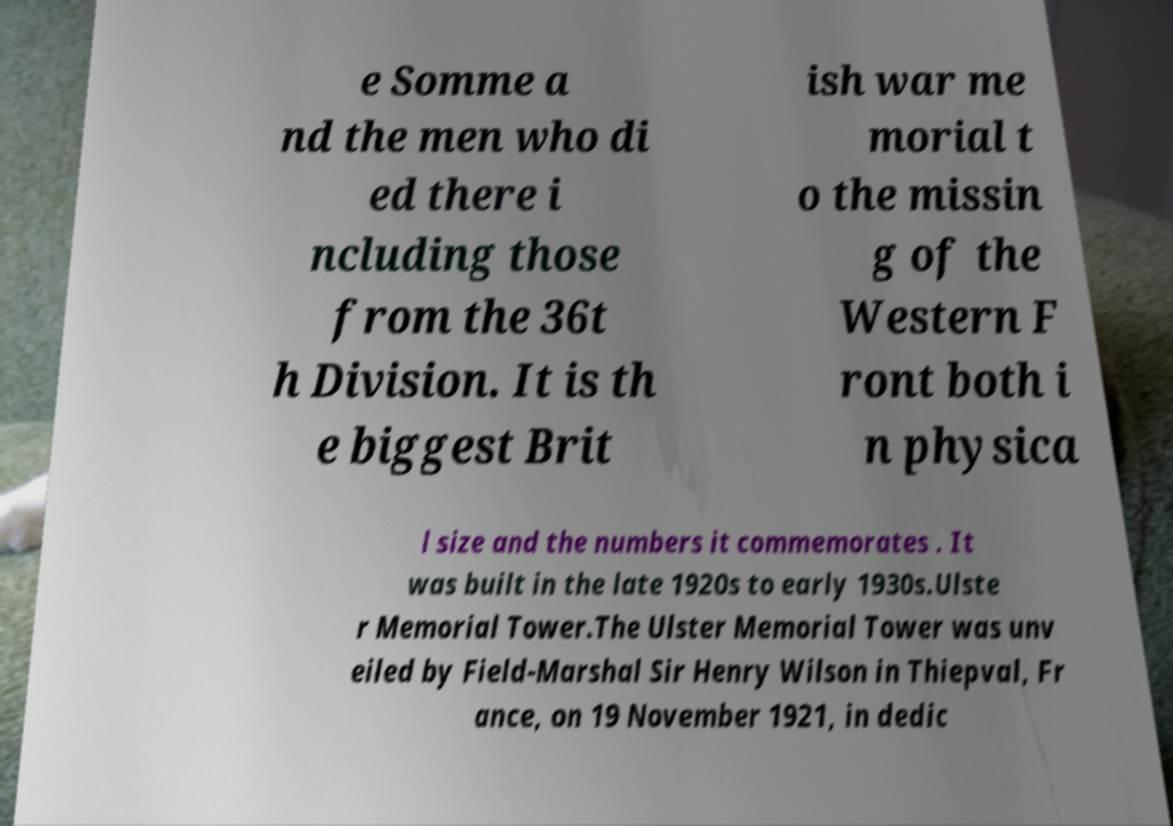There's text embedded in this image that I need extracted. Can you transcribe it verbatim? e Somme a nd the men who di ed there i ncluding those from the 36t h Division. It is th e biggest Brit ish war me morial t o the missin g of the Western F ront both i n physica l size and the numbers it commemorates . It was built in the late 1920s to early 1930s.Ulste r Memorial Tower.The Ulster Memorial Tower was unv eiled by Field-Marshal Sir Henry Wilson in Thiepval, Fr ance, on 19 November 1921, in dedic 